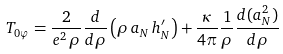Convert formula to latex. <formula><loc_0><loc_0><loc_500><loc_500>T _ { 0 \varphi } & = \frac { 2 } { e ^ { 2 } \, \rho } \frac { d } { d \rho } \left ( \rho \, a _ { N } \, h ^ { \prime } _ { N } \right ) + \frac { \kappa } { 4 \pi } \frac { 1 } { \rho } \frac { d ( a _ { N } ^ { 2 } ) } { d \rho }</formula> 